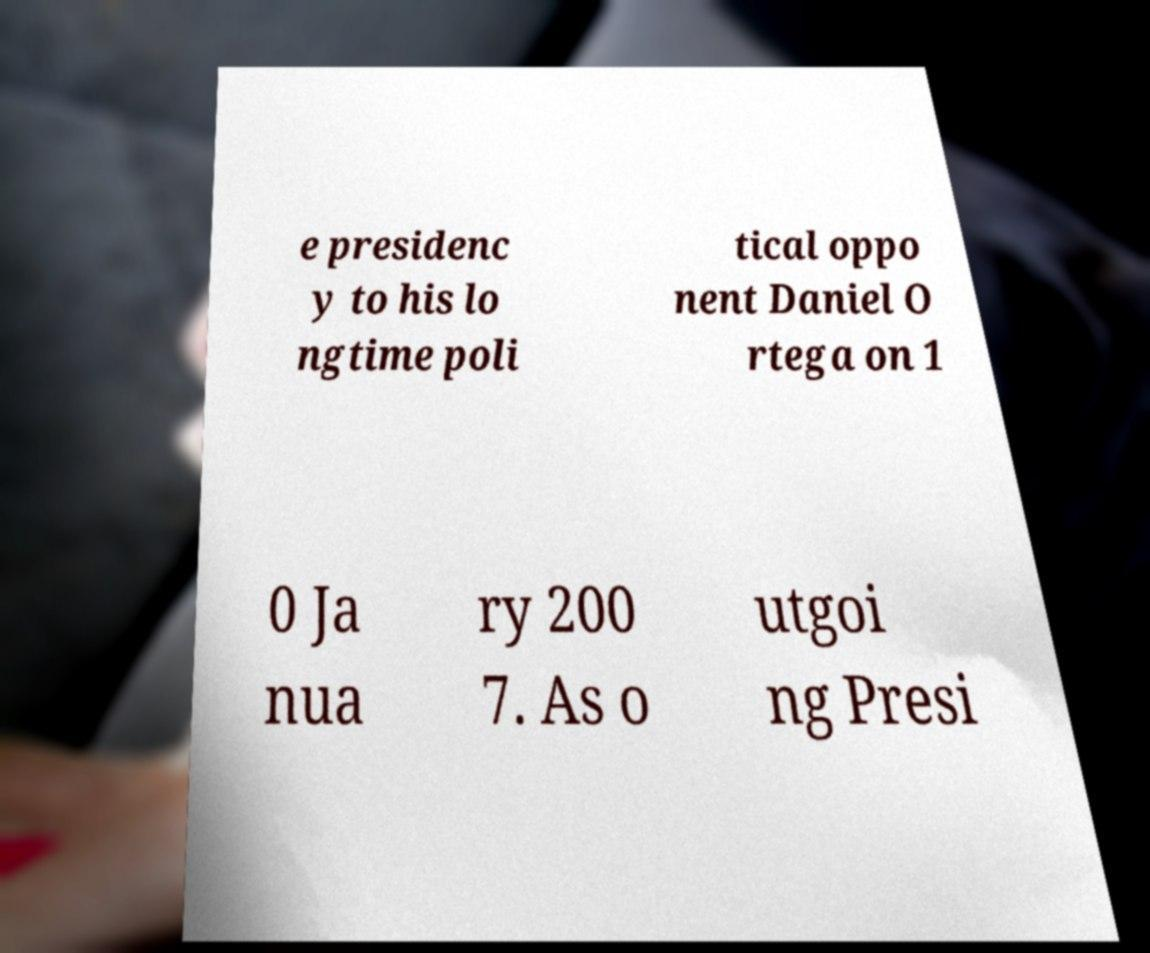Please read and relay the text visible in this image. What does it say? e presidenc y to his lo ngtime poli tical oppo nent Daniel O rtega on 1 0 Ja nua ry 200 7. As o utgoi ng Presi 